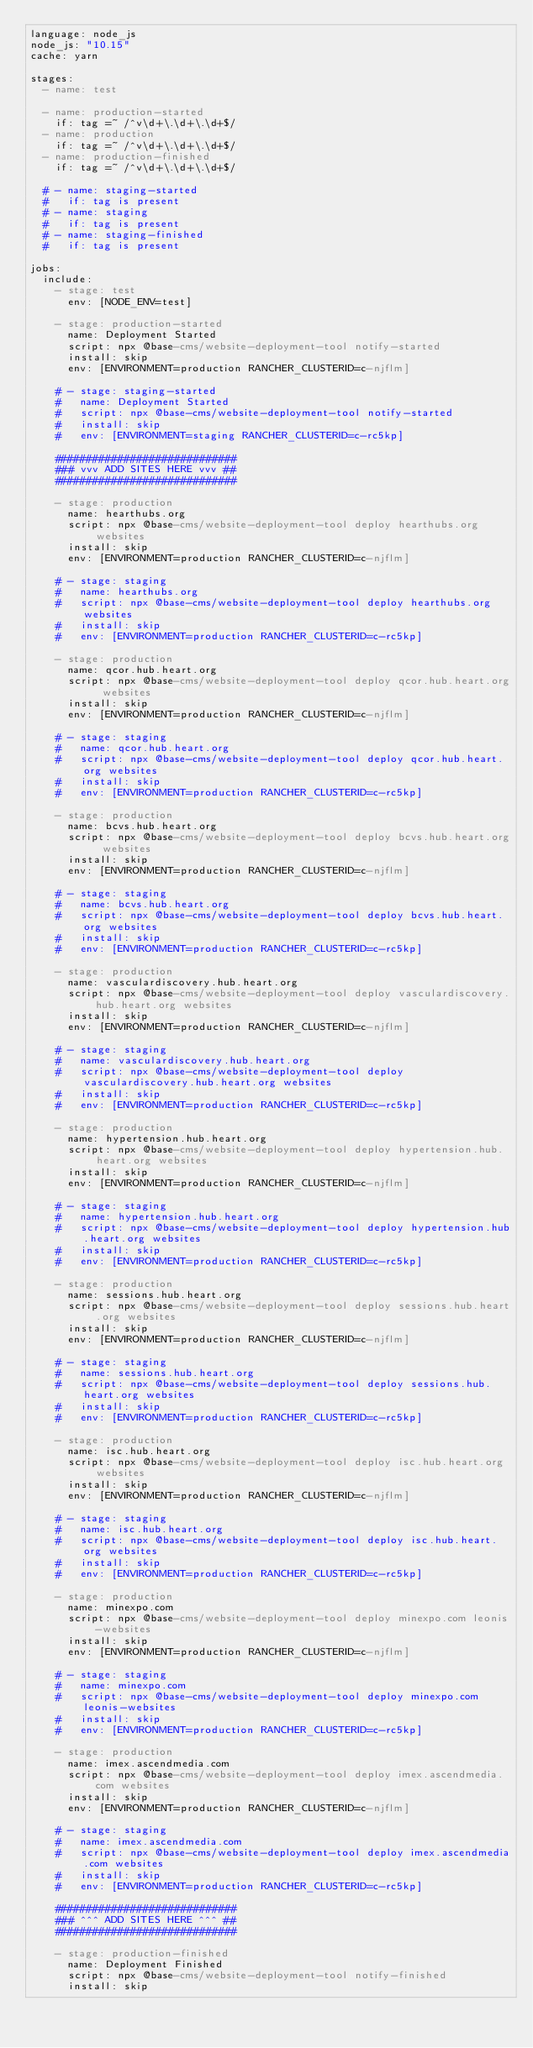Convert code to text. <code><loc_0><loc_0><loc_500><loc_500><_YAML_>language: node_js
node_js: "10.15"
cache: yarn

stages:
  - name: test

  - name: production-started
    if: tag =~ /^v\d+\.\d+\.\d+$/
  - name: production
    if: tag =~ /^v\d+\.\d+\.\d+$/
  - name: production-finished
    if: tag =~ /^v\d+\.\d+\.\d+$/

  # - name: staging-started
  #   if: tag is present
  # - name: staging
  #   if: tag is present
  # - name: staging-finished
  #   if: tag is present

jobs:
  include:
    - stage: test
      env: [NODE_ENV=test]

    - stage: production-started
      name: Deployment Started
      script: npx @base-cms/website-deployment-tool notify-started
      install: skip
      env: [ENVIRONMENT=production RANCHER_CLUSTERID=c-njflm]

    # - stage: staging-started
    #   name: Deployment Started
    #   script: npx @base-cms/website-deployment-tool notify-started
    #   install: skip
    #   env: [ENVIRONMENT=staging RANCHER_CLUSTERID=c-rc5kp]

    #############################
    ### vvv ADD SITES HERE vvv ##
    #############################

    - stage: production
      name: hearthubs.org
      script: npx @base-cms/website-deployment-tool deploy hearthubs.org websites
      install: skip
      env: [ENVIRONMENT=production RANCHER_CLUSTERID=c-njflm]

    # - stage: staging
    #   name: hearthubs.org
    #   script: npx @base-cms/website-deployment-tool deploy hearthubs.org websites
    #   install: skip
    #   env: [ENVIRONMENT=production RANCHER_CLUSTERID=c-rc5kp]

    - stage: production
      name: qcor.hub.heart.org
      script: npx @base-cms/website-deployment-tool deploy qcor.hub.heart.org websites
      install: skip
      env: [ENVIRONMENT=production RANCHER_CLUSTERID=c-njflm]

    # - stage: staging
    #   name: qcor.hub.heart.org
    #   script: npx @base-cms/website-deployment-tool deploy qcor.hub.heart.org websites
    #   install: skip
    #   env: [ENVIRONMENT=production RANCHER_CLUSTERID=c-rc5kp]

    - stage: production
      name: bcvs.hub.heart.org
      script: npx @base-cms/website-deployment-tool deploy bcvs.hub.heart.org websites
      install: skip
      env: [ENVIRONMENT=production RANCHER_CLUSTERID=c-njflm]

    # - stage: staging
    #   name: bcvs.hub.heart.org
    #   script: npx @base-cms/website-deployment-tool deploy bcvs.hub.heart.org websites
    #   install: skip
    #   env: [ENVIRONMENT=production RANCHER_CLUSTERID=c-rc5kp]

    - stage: production
      name: vasculardiscovery.hub.heart.org
      script: npx @base-cms/website-deployment-tool deploy vasculardiscovery.hub.heart.org websites
      install: skip
      env: [ENVIRONMENT=production RANCHER_CLUSTERID=c-njflm]

    # - stage: staging
    #   name: vasculardiscovery.hub.heart.org
    #   script: npx @base-cms/website-deployment-tool deploy vasculardiscovery.hub.heart.org websites
    #   install: skip
    #   env: [ENVIRONMENT=production RANCHER_CLUSTERID=c-rc5kp]

    - stage: production
      name: hypertension.hub.heart.org
      script: npx @base-cms/website-deployment-tool deploy hypertension.hub.heart.org websites
      install: skip
      env: [ENVIRONMENT=production RANCHER_CLUSTERID=c-njflm]

    # - stage: staging
    #   name: hypertension.hub.heart.org
    #   script: npx @base-cms/website-deployment-tool deploy hypertension.hub.heart.org websites
    #   install: skip
    #   env: [ENVIRONMENT=production RANCHER_CLUSTERID=c-rc5kp]

    - stage: production
      name: sessions.hub.heart.org
      script: npx @base-cms/website-deployment-tool deploy sessions.hub.heart.org websites
      install: skip
      env: [ENVIRONMENT=production RANCHER_CLUSTERID=c-njflm]

    # - stage: staging
    #   name: sessions.hub.heart.org
    #   script: npx @base-cms/website-deployment-tool deploy sessions.hub.heart.org websites
    #   install: skip
    #   env: [ENVIRONMENT=production RANCHER_CLUSTERID=c-rc5kp]

    - stage: production
      name: isc.hub.heart.org
      script: npx @base-cms/website-deployment-tool deploy isc.hub.heart.org websites
      install: skip
      env: [ENVIRONMENT=production RANCHER_CLUSTERID=c-njflm]

    # - stage: staging
    #   name: isc.hub.heart.org
    #   script: npx @base-cms/website-deployment-tool deploy isc.hub.heart.org websites
    #   install: skip
    #   env: [ENVIRONMENT=production RANCHER_CLUSTERID=c-rc5kp]

    - stage: production
      name: minexpo.com
      script: npx @base-cms/website-deployment-tool deploy minexpo.com leonis-websites
      install: skip
      env: [ENVIRONMENT=production RANCHER_CLUSTERID=c-njflm]

    # - stage: staging
    #   name: minexpo.com
    #   script: npx @base-cms/website-deployment-tool deploy minexpo.com leonis-websites
    #   install: skip
    #   env: [ENVIRONMENT=production RANCHER_CLUSTERID=c-rc5kp]

    - stage: production
      name: imex.ascendmedia.com
      script: npx @base-cms/website-deployment-tool deploy imex.ascendmedia.com websites
      install: skip
      env: [ENVIRONMENT=production RANCHER_CLUSTERID=c-njflm]

    # - stage: staging
    #   name: imex.ascendmedia.com
    #   script: npx @base-cms/website-deployment-tool deploy imex.ascendmedia.com websites
    #   install: skip
    #   env: [ENVIRONMENT=production RANCHER_CLUSTERID=c-rc5kp]

    #############################
    ### ^^^ ADD SITES HERE ^^^ ##
    #############################

    - stage: production-finished
      name: Deployment Finished
      script: npx @base-cms/website-deployment-tool notify-finished
      install: skip</code> 